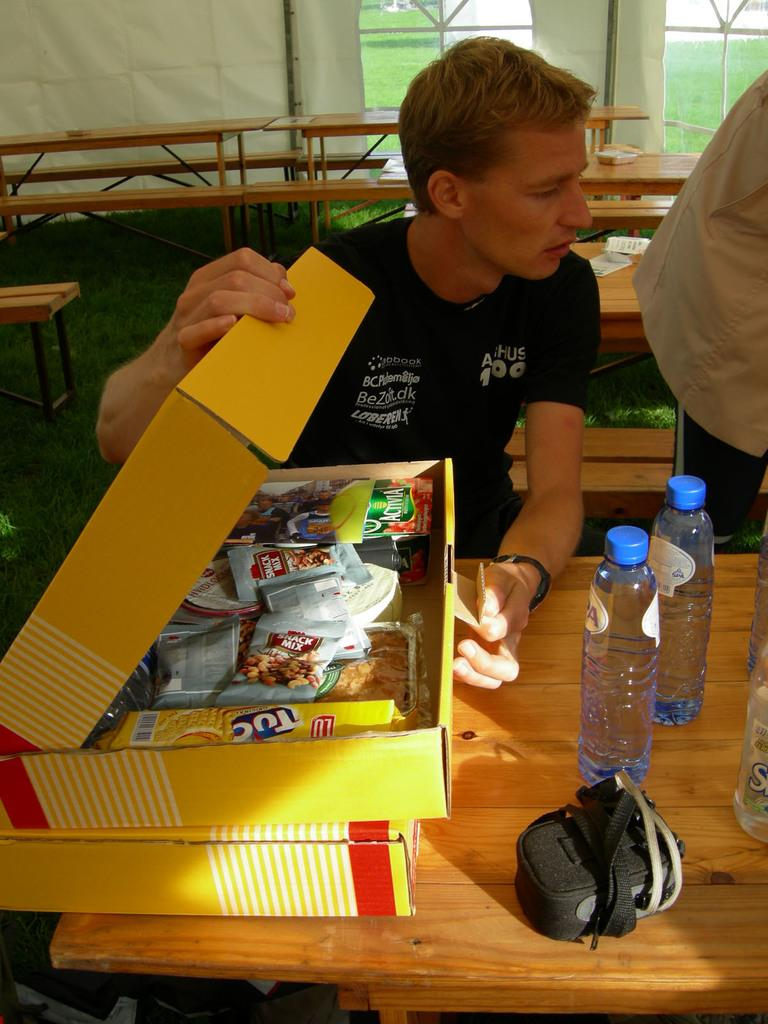Who is present in the image? There is a man in the image. What is the man doing in the image? The man is sitting. What is the man wearing in the image? The man is wearing a black t-shirt. What can be seen on the right side of the image? There are water bottles on the right side of the image. What is the reason for the man cracking the whip in the image? There is no whip present in the image, so the man is not cracking a whip. 